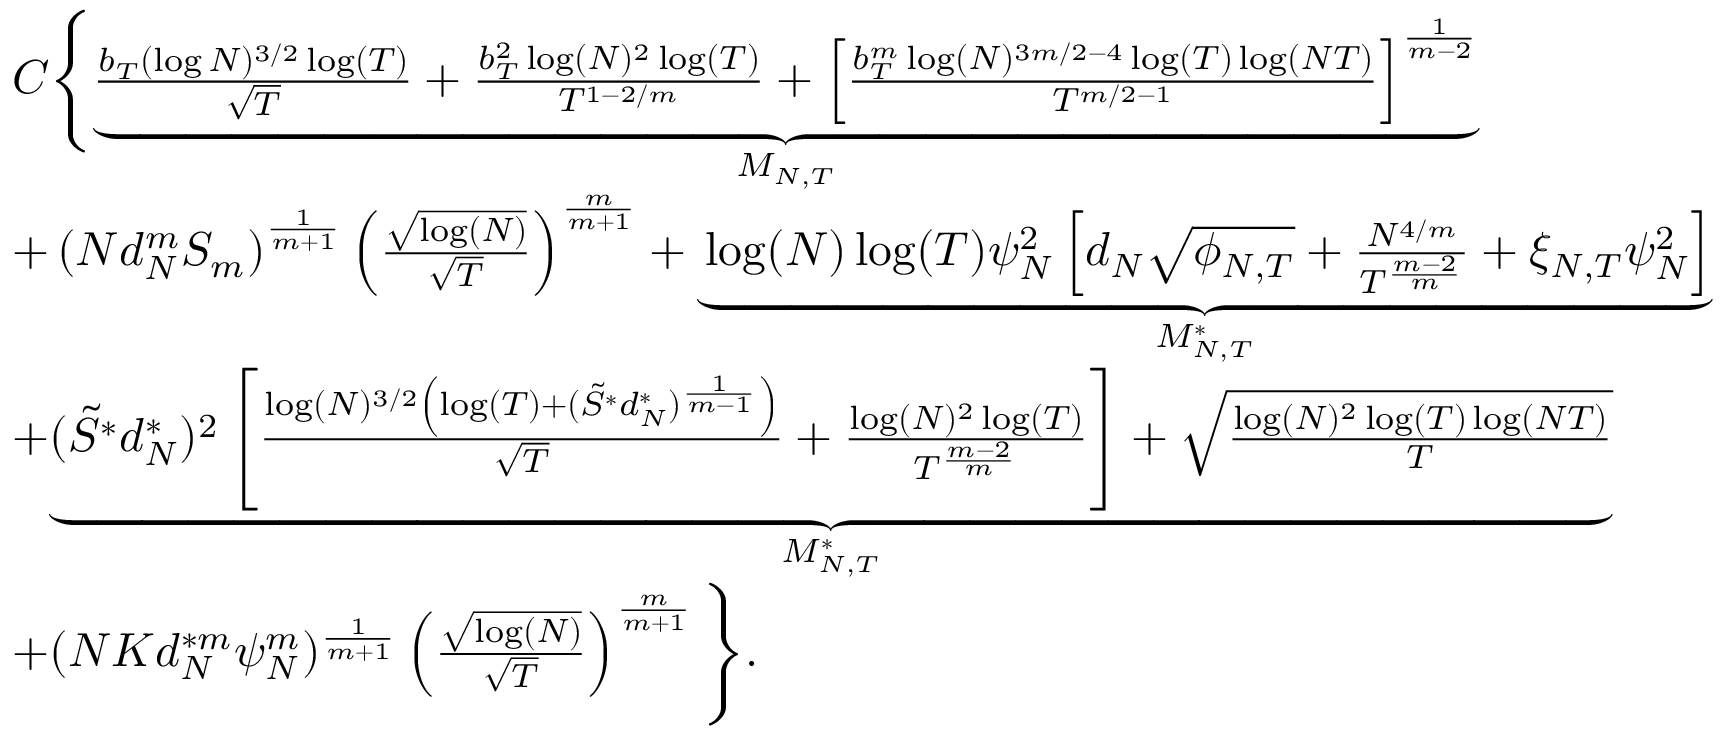Convert formula to latex. <formula><loc_0><loc_0><loc_500><loc_500>\begin{array} { r l } & { C \left \{ \underset { { M _ { N , T } } } { \underbrace { \frac { b _ { T } ( \log N ) ^ { 3 / 2 } \log ( T ) } { \sqrt { T } } + \frac { b _ { T } ^ { 2 } \log ( N ) ^ { 2 } \log ( T ) } { T ^ { 1 - 2 / m } } + \left [ \frac { b _ { T } ^ { m } \log ( N ) ^ { 3 m / 2 - 4 } \log ( T ) \log ( N T ) } { T ^ { m / 2 - 1 } } \right ] ^ { \frac { 1 } { m - 2 } } } } } \\ & { + \left ( N d _ { N } ^ { m } S _ { m } \right ) ^ { \frac { 1 } { m + 1 } } \left ( \frac { \sqrt { \log ( N ) } } { \sqrt { T } } \right ) ^ { \frac { m } { m + 1 } } + \underset { { M _ { N , T } ^ { * } } } { \underbrace { \log ( N ) \log ( T ) \psi _ { N } ^ { 2 } \left [ d _ { N } \sqrt { \phi _ { N , T } } + \frac { N ^ { 4 / m } } { T ^ { \frac { m - 2 } { m } } } + \xi _ { N , T } \psi _ { N } ^ { 2 } \right ] } } } \\ & { + \underset { { M _ { N , T } ^ { * } } } { \underbrace { ( \tilde { S } ^ { * } d _ { N } ^ { * } ) ^ { 2 } \left [ \frac { \log ( N ) ^ { 3 / 2 } \left ( \log ( T ) + ( \tilde { S } ^ { * } d _ { N } ^ { * } ) ^ { \frac { 1 } { m - 1 } } \right ) } { \sqrt { T } } + \frac { \log ( N ) ^ { 2 } \log ( T ) } { T ^ { \frac { m - 2 } { m } } } \right ] + \sqrt { \frac { \log ( N ) ^ { 2 } \log ( T ) \log ( N T ) } { T } } } } } \\ & { + ( N K d _ { N } ^ { * m } \psi _ { N } ^ { m } ) ^ { \frac { 1 } { m + 1 } } \left ( \frac { \sqrt { \log ( N ) } } { \sqrt { T } } \right ) ^ { \frac { m } { m + 1 } } \right \} . } \end{array}</formula> 